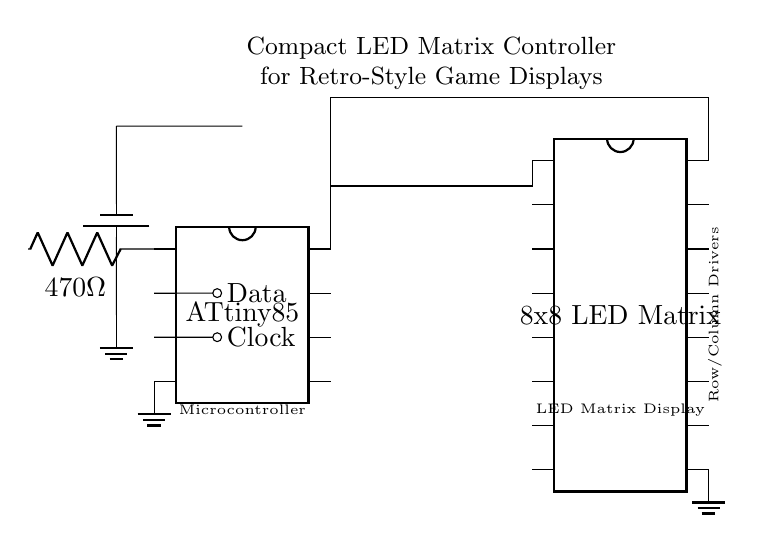What type of microcontroller is used? The circuit uses an ATtiny85, which is represented as a dip chip in the diagram.
Answer: ATtiny85 How many pins does the LED matrix have? The 8x8 LED matrix is shown as a dip chip with 16 pins in the circuit, indicating the total number of connections available.
Answer: 16 What is the resistor value connected to the microcontroller? The circuit shows a resistor labeled as 470 Ohms connected to one of the microcontroller pins, indicating its value.
Answer: 470 Ohm Where does the data signal originate? The data signal originates from pin 2 of the microcontroller, which is indicated by the short connection and labeled 'Data'.
Answer: Pin 2 How many rows are controlled by the LED matrix? The diagram represents the matrix as an 8x8 configuration, indicating that it has 8 rows that can be controlled for display purposes.
Answer: 8 What is the purpose of the battery in this circuit? The battery serves as the power supply, providing the necessary voltage for the circuit to operate, as indicated by its connection to the microcontroller and ground.
Answer: Power supply How is the microcontroller connected to the LED matrix? The microcontroller is connected to the LED matrix through its pin 8, which is linked to one of the matrix's pins, facilitating communication between the two components.
Answer: Pin 8 